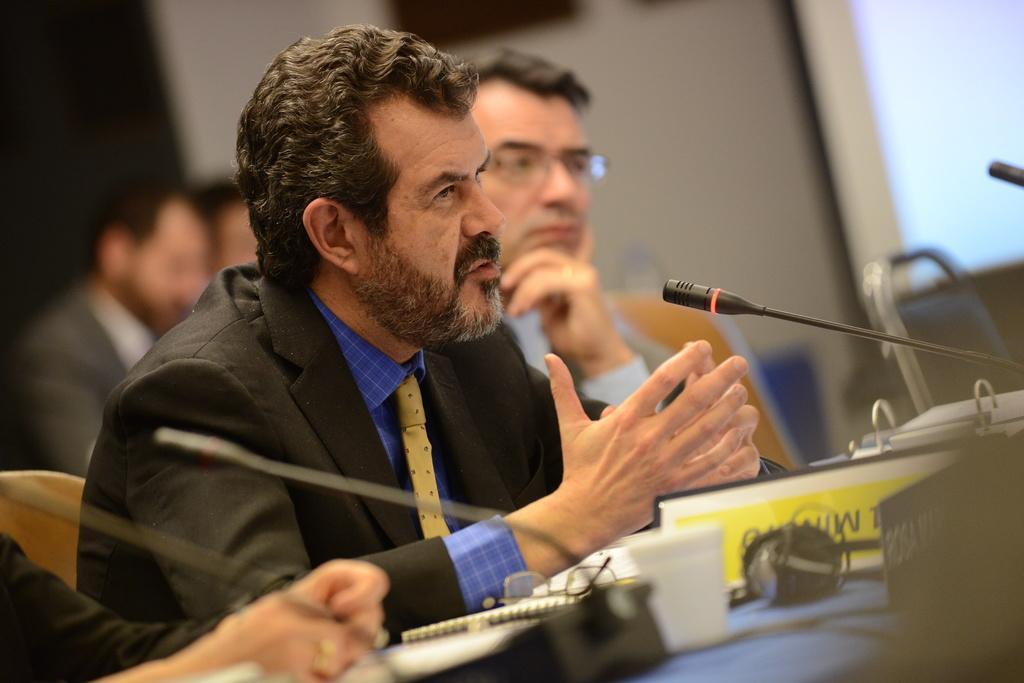How would you summarize this image in a sentence or two? In this image there are people sitting on the chairs. In front of them there is a table. On top of it there are mike's, name board and some other objects. In the background of the image there is a photo frame on the wall. On the left side of the image there is a door. On the right side of the image there is a screen. 